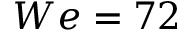Convert formula to latex. <formula><loc_0><loc_0><loc_500><loc_500>W e = 7 2</formula> 